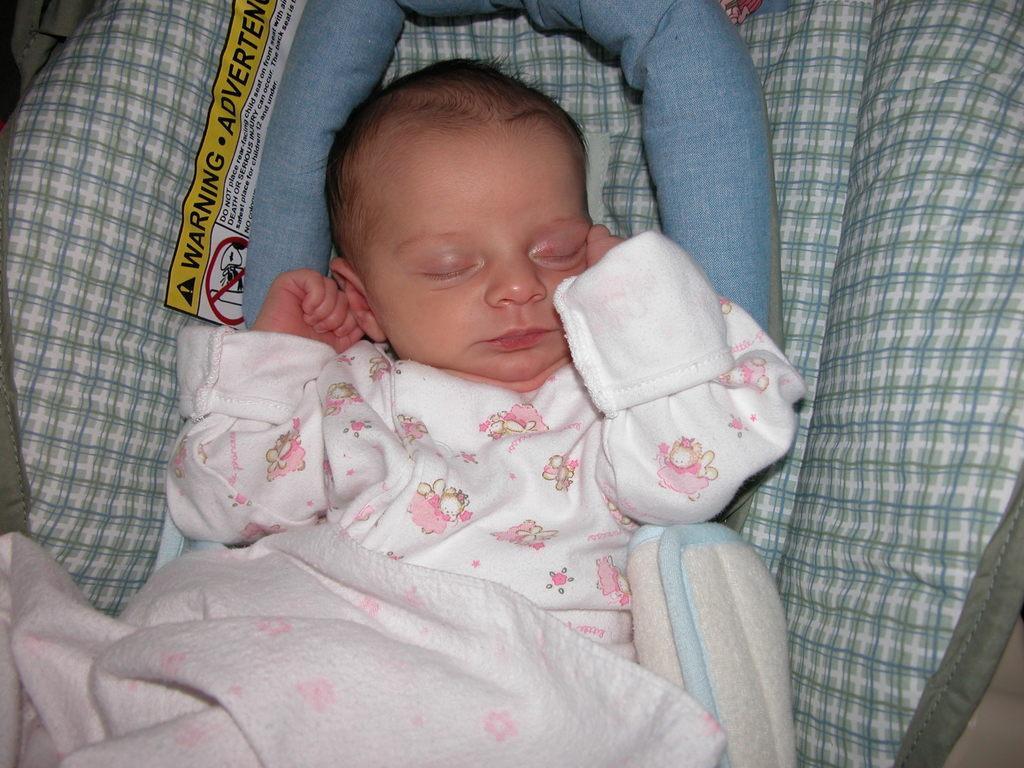Describe this image in one or two sentences. This is a small baby sleeping in the kids bed. I can see a blanket covered on the baby. This looks like a pillow. 